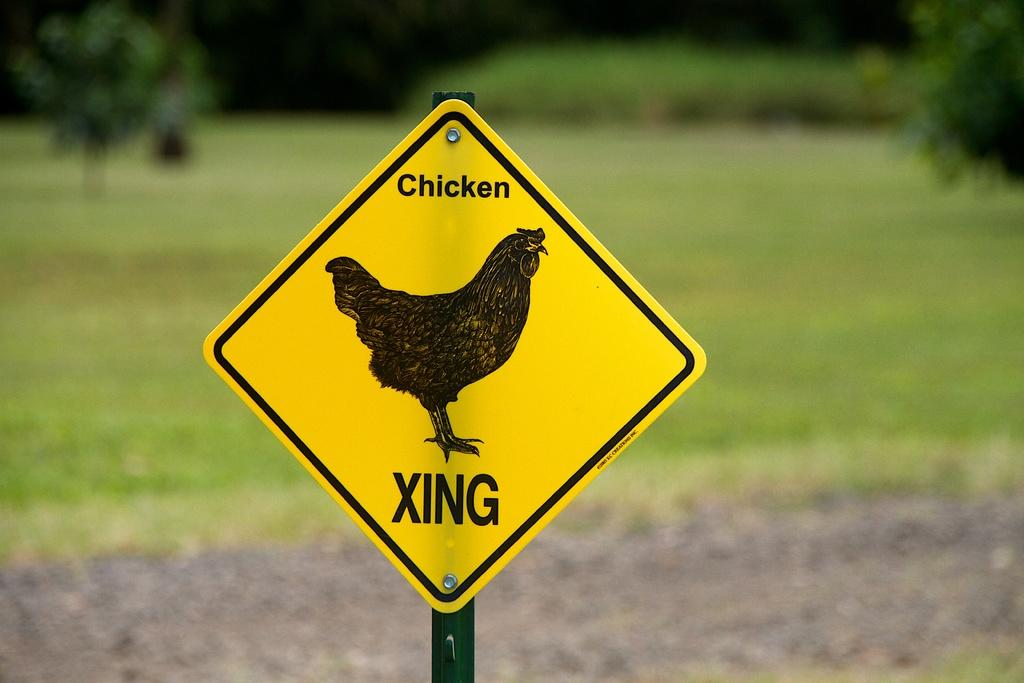What is located in the foreground of the image? There is a sign pole in the foreground of the image. What can be seen in the background of the image? There are trees and grassland in the background of the image. What type of bait is being used to catch fish in the image? There is no fishing or bait present in the image; it features a sign pole and background elements of trees and grassland. 